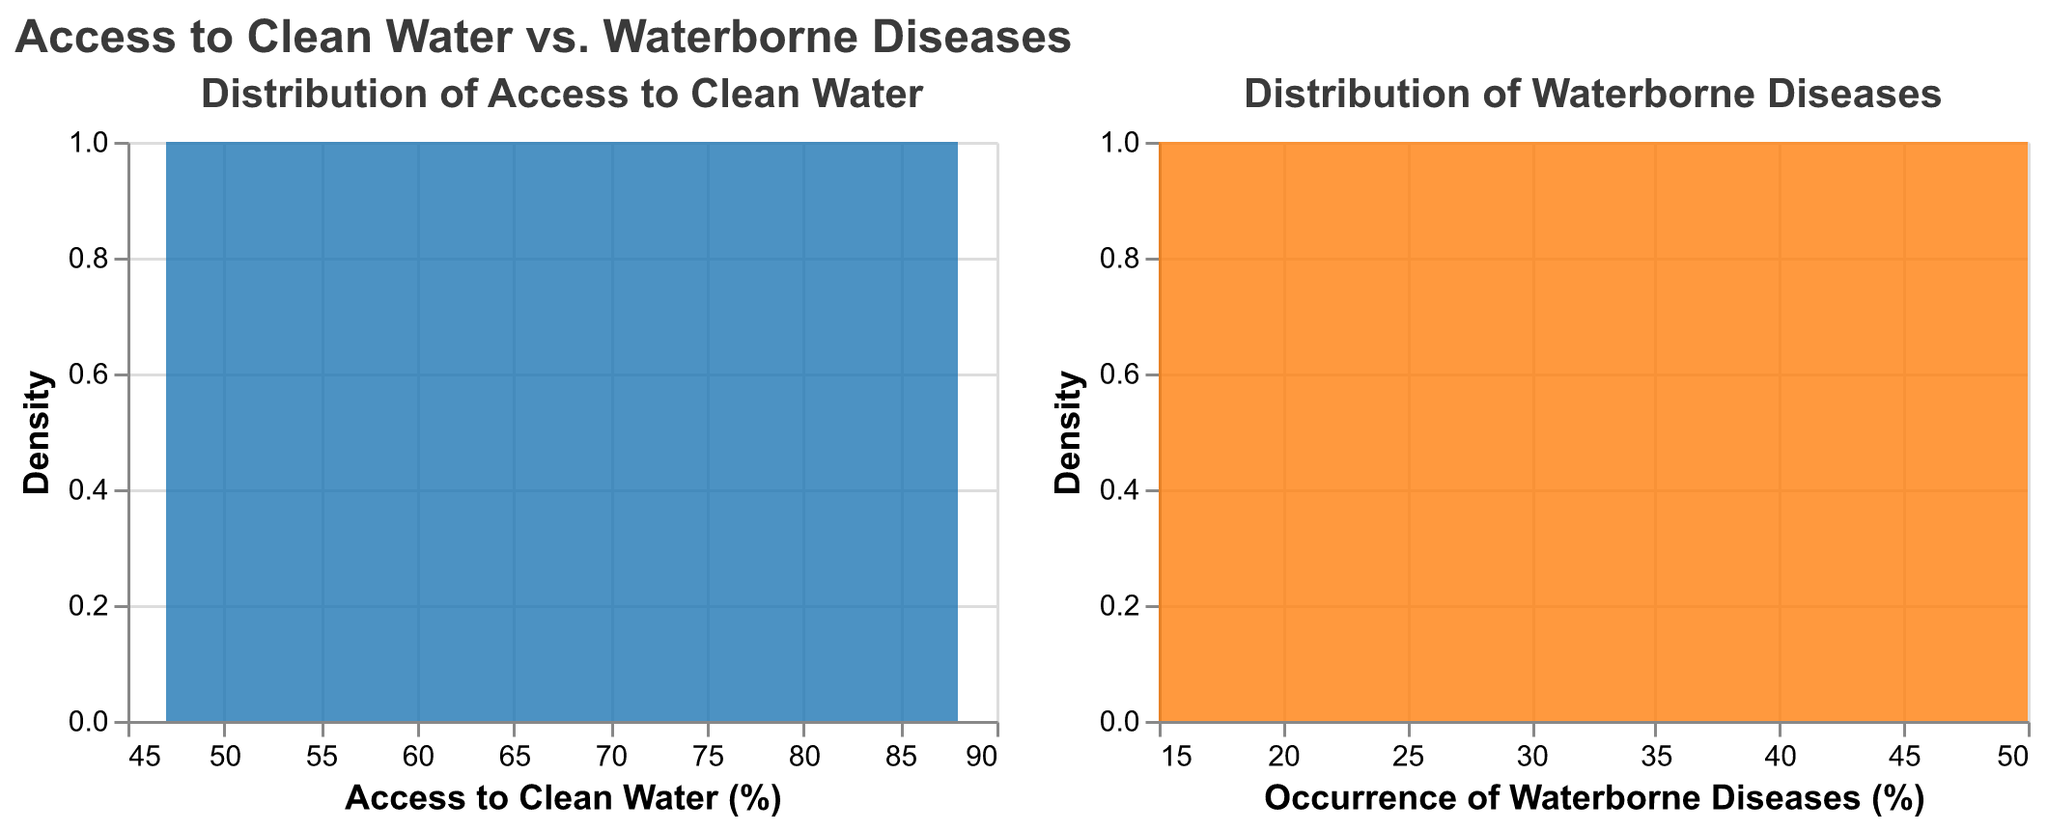What is the title of the plot? The title of the plot is located at the top of the figure. It reads "Access to Clean Water vs. Waterborne Diseases".
Answer: Access to Clean Water vs. Waterborne Diseases Which color is used for the plot depicting the distribution of access to clean water? The plot depicting the distribution of access to clean water uses the color blue.
Answer: Blue How many countries are represented in the data? Each line in the data represents a country. By counting the lines, there are 10 countries visible in the plot.
Answer: 10 Which region appears most frequently in the dataset? East Africa appears most frequently, as it is mentioned for Ethiopia, Kenya, and Uganda, making a total of 3 occurrences.
Answer: East Africa What is the range of the x-axis for the access to clean water plot? The x-axis for the access to clean water plot ranges from approximately 45 to 90, as observed from the tick marks and labels on the x-axis.
Answer: Approximately 45 to 90 Which country has the highest access to clean water? The country with the highest access to clean water is India, as indicated by the value 88 in the access to clean water data.
Answer: India Which country has the highest occurrence of waterborne diseases? The country with the highest occurrence of waterborne diseases is Mozambique, with a value of 50.
Answer: Mozambique What is the average access to clean water for countries in East Africa? To calculate the average, sum the access to clean water percentage for East African countries (Ethiopia: 57, Kenya: 65, Uganda: 63) and divide by 3. The calculation is (57 + 65 + 63) / 3 = 185 / 3 = 61.67.
Answer: 61.67 Which plot shows a wider spread between the highest and lowest values? By observing the range on the x-axes, the plot for "Occurrence of Waterborne Diseases" has values ranging from approximately 15 to 50, while "Access to Clean Water" ranges from approximately 45 to 90. The "Occurrence of Waterborne Diseases" plot has a wider spread (35) compared to the "Access to Clean Water" plot (45).
Answer: Occurrence of Waterborne Diseases Compare the density peaks of both plots. Which plot shows a higher peak? By comparing the heights of the peaks in both density plots, the distribution of access to clean water has a higher peak compared to the distribution of waterborne diseases.
Answer: Access to Clean Water 